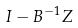<formula> <loc_0><loc_0><loc_500><loc_500>I - B ^ { - 1 } Z</formula> 